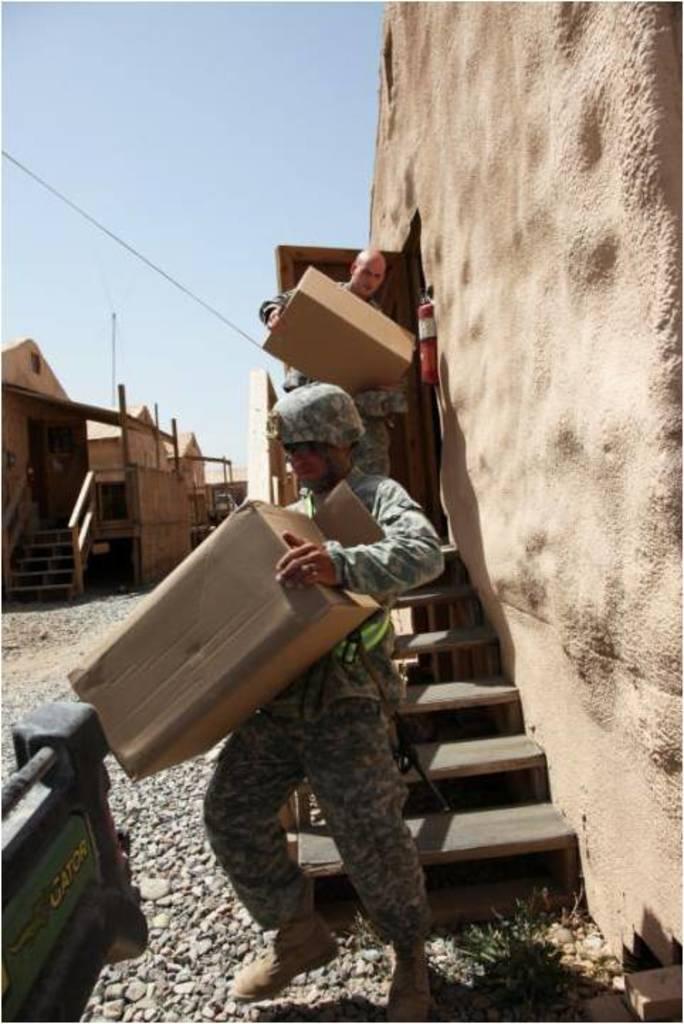Describe this image in one or two sentences. In this image I can see 2 people holding cartons. There are stairs and a wall on the right. There are buildings on the left and sky at the top. 